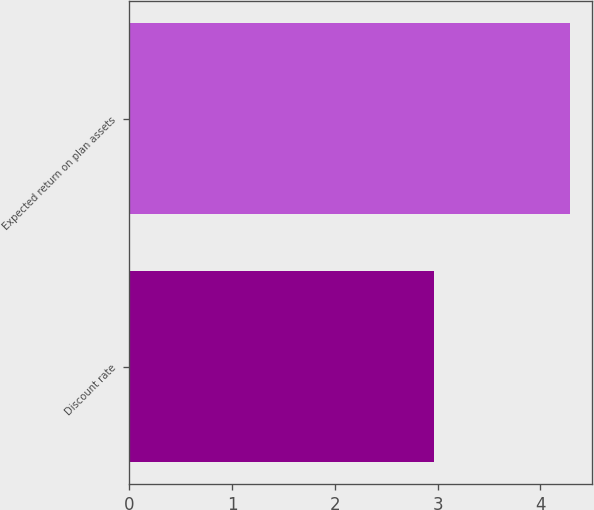<chart> <loc_0><loc_0><loc_500><loc_500><bar_chart><fcel>Discount rate<fcel>Expected return on plan assets<nl><fcel>2.96<fcel>4.29<nl></chart> 